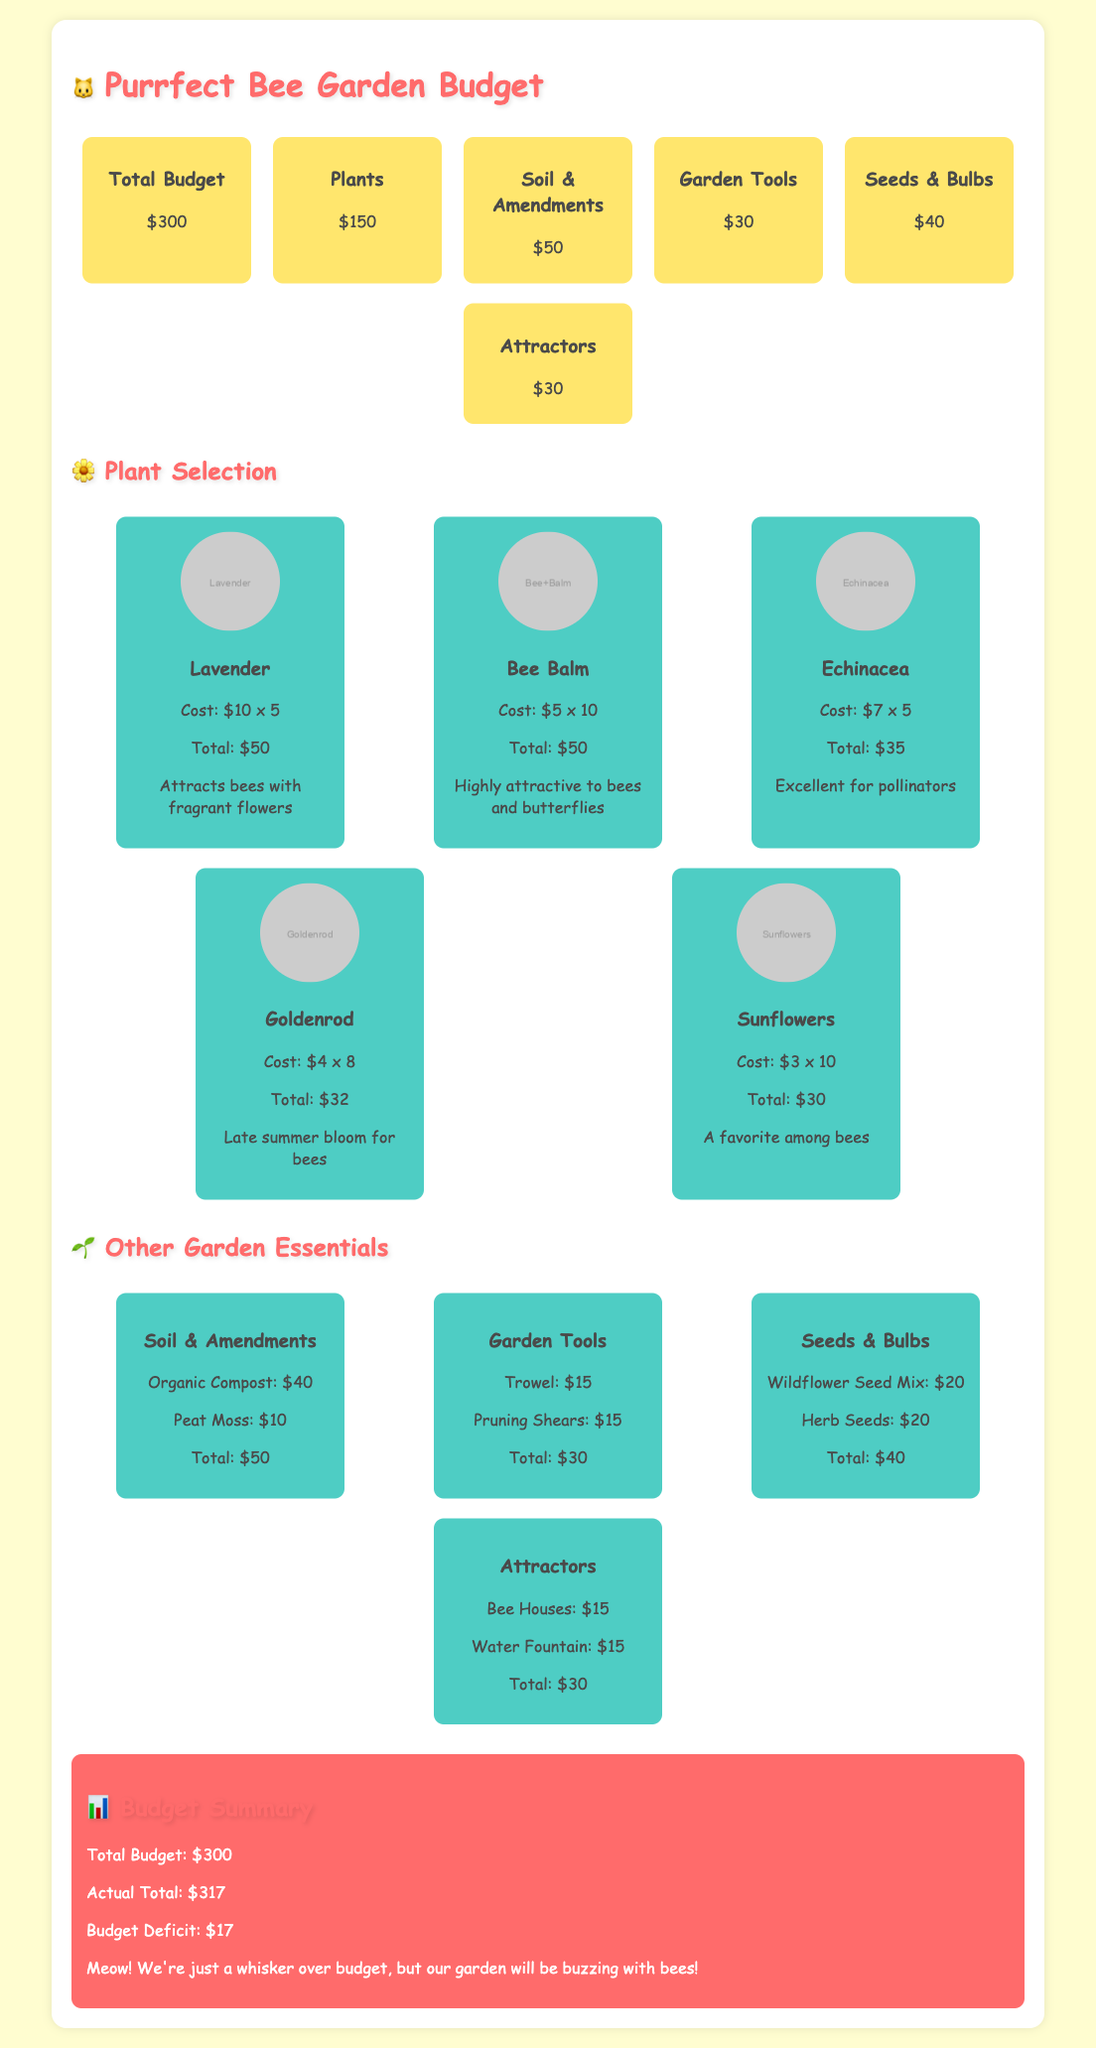What is the total budget? The total budget is stated in the budget overview section, which reads $300.
Answer: $300 How much is allocated for plants? The budget overview lists the allocation for plants as $150.
Answer: $150 What flower is mentioned as attracting bees with fragrant flowers? The plant card for Lavender states that it attracts bees with its fragrant flowers.
Answer: Lavender What is the cost of the Bee Balm plants? The plant card for Bee Balm indicates the cost: $5 times 10, totaling $50.
Answer: $50 How much is spent on garden tools? The budget overview lists the amount spent on garden tools as $30.
Answer: $30 What is the budget deficit? The summary section states the budget deficit as $17.
Answer: $17 Which plant is a favorite among bees? The plant card for Sunflowers mentions that it is a favorite among bees.
Answer: Sunflowers What are the two attractors listed in the document? The attractors listed are Bee Houses and Water Fountain in the garden essentials section.
Answer: Bee Houses, Water Fountain What is the total cost of the soil and amendments? The document specifies the total cost for soil and amendments is $50.
Answer: $50 